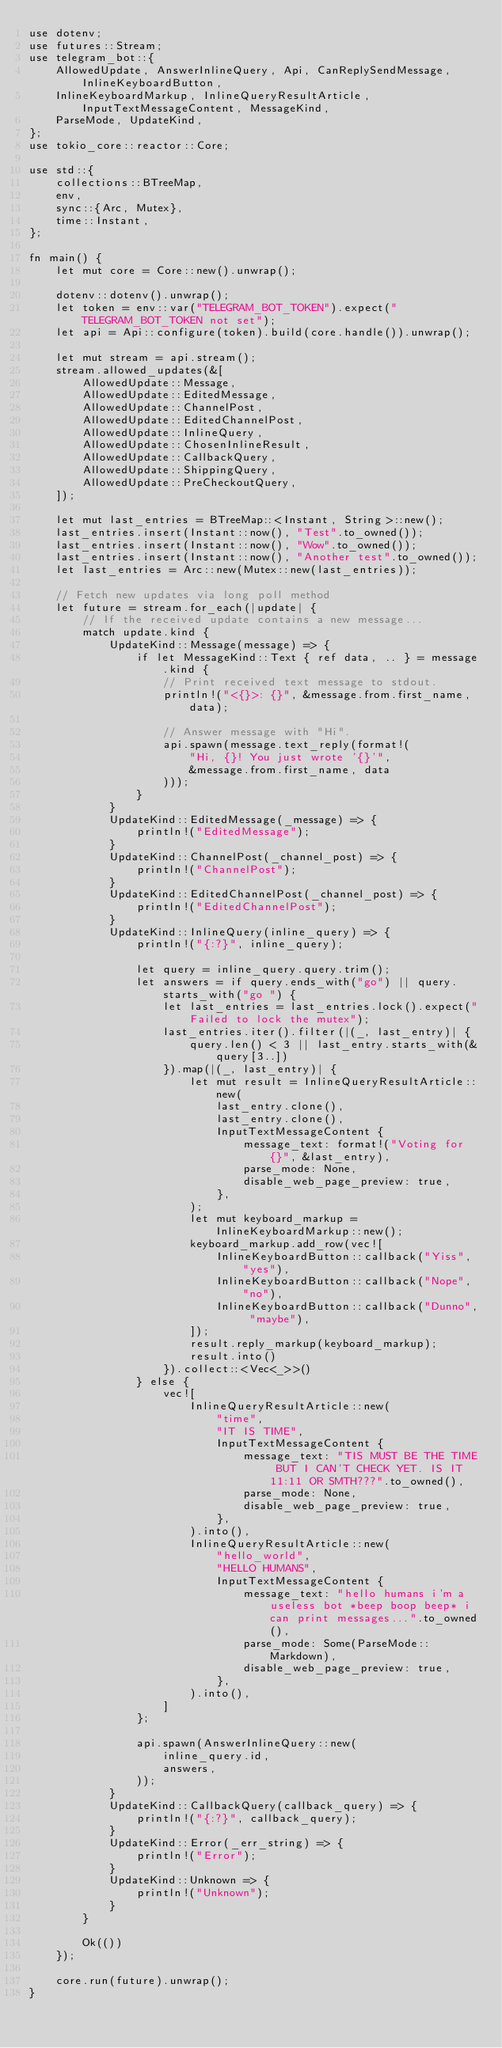Convert code to text. <code><loc_0><loc_0><loc_500><loc_500><_Rust_>use dotenv;
use futures::Stream;
use telegram_bot::{
    AllowedUpdate, AnswerInlineQuery, Api, CanReplySendMessage, InlineKeyboardButton,
    InlineKeyboardMarkup, InlineQueryResultArticle, InputTextMessageContent, MessageKind,
    ParseMode, UpdateKind,
};
use tokio_core::reactor::Core;

use std::{
    collections::BTreeMap,
    env,
    sync::{Arc, Mutex},
    time::Instant,
};

fn main() {
    let mut core = Core::new().unwrap();

    dotenv::dotenv().unwrap();
    let token = env::var("TELEGRAM_BOT_TOKEN").expect("TELEGRAM_BOT_TOKEN not set");
    let api = Api::configure(token).build(core.handle()).unwrap();

    let mut stream = api.stream();
    stream.allowed_updates(&[
        AllowedUpdate::Message,
        AllowedUpdate::EditedMessage,
        AllowedUpdate::ChannelPost,
        AllowedUpdate::EditedChannelPost,
        AllowedUpdate::InlineQuery,
        AllowedUpdate::ChosenInlineResult,
        AllowedUpdate::CallbackQuery,
        AllowedUpdate::ShippingQuery,
        AllowedUpdate::PreCheckoutQuery,
    ]);

    let mut last_entries = BTreeMap::<Instant, String>::new();
    last_entries.insert(Instant::now(), "Test".to_owned());
    last_entries.insert(Instant::now(), "Wow".to_owned());
    last_entries.insert(Instant::now(), "Another test".to_owned());
    let last_entries = Arc::new(Mutex::new(last_entries));

    // Fetch new updates via long poll method
    let future = stream.for_each(|update| {
        // If the received update contains a new message...
        match update.kind {
            UpdateKind::Message(message) => {
                if let MessageKind::Text { ref data, .. } = message.kind {
                    // Print received text message to stdout.
                    println!("<{}>: {}", &message.from.first_name, data);

                    // Answer message with "Hi".
                    api.spawn(message.text_reply(format!(
                        "Hi, {}! You just wrote '{}'",
                        &message.from.first_name, data
                    )));
                }
            }
            UpdateKind::EditedMessage(_message) => {
                println!("EditedMessage");
            }
            UpdateKind::ChannelPost(_channel_post) => {
                println!("ChannelPost");
            }
            UpdateKind::EditedChannelPost(_channel_post) => {
                println!("EditedChannelPost");
            }
            UpdateKind::InlineQuery(inline_query) => {
                println!("{:?}", inline_query);

                let query = inline_query.query.trim();
                let answers = if query.ends_with("go") || query.starts_with("go ") {
                    let last_entries = last_entries.lock().expect("Failed to lock the mutex");
                    last_entries.iter().filter(|(_, last_entry)| {
                        query.len() < 3 || last_entry.starts_with(&query[3..])
                    }).map(|(_, last_entry)| {
                        let mut result = InlineQueryResultArticle::new(
                            last_entry.clone(),
                            last_entry.clone(),
                            InputTextMessageContent {
                                message_text: format!("Voting for {}", &last_entry),
                                parse_mode: None,
                                disable_web_page_preview: true,
                            },
                        );
                        let mut keyboard_markup = InlineKeyboardMarkup::new();
                        keyboard_markup.add_row(vec![
                            InlineKeyboardButton::callback("Yiss", "yes"),
                            InlineKeyboardButton::callback("Nope", "no"),
                            InlineKeyboardButton::callback("Dunno", "maybe"),
                        ]);
                        result.reply_markup(keyboard_markup);
                        result.into()
                    }).collect::<Vec<_>>()
                } else {
                    vec![
                        InlineQueryResultArticle::new(
                            "time",
                            "IT IS TIME",
                            InputTextMessageContent {
                                message_text: "TIS MUST BE THE TIME BUT I CAN'T CHECK YET. IS IT 11:11 OR SMTH???".to_owned(),
                                parse_mode: None,
                                disable_web_page_preview: true,
                            },
                        ).into(),
                        InlineQueryResultArticle::new(
                            "hello_world",
                            "HELLO HUMANS",
                            InputTextMessageContent {
                                message_text: "hello humans i'm a useless bot *beep boop beep* i can print messages...".to_owned(),
                                parse_mode: Some(ParseMode::Markdown),
                                disable_web_page_preview: true,
                            },
                        ).into(),
                    ]
                };

                api.spawn(AnswerInlineQuery::new(
                    inline_query.id,
                    answers,
                ));
            }
            UpdateKind::CallbackQuery(callback_query) => {
                println!("{:?}", callback_query);
            }
            UpdateKind::Error(_err_string) => {
                println!("Error");
            }
            UpdateKind::Unknown => {
                println!("Unknown");
            }
        }

        Ok(())
    });

    core.run(future).unwrap();
}
</code> 